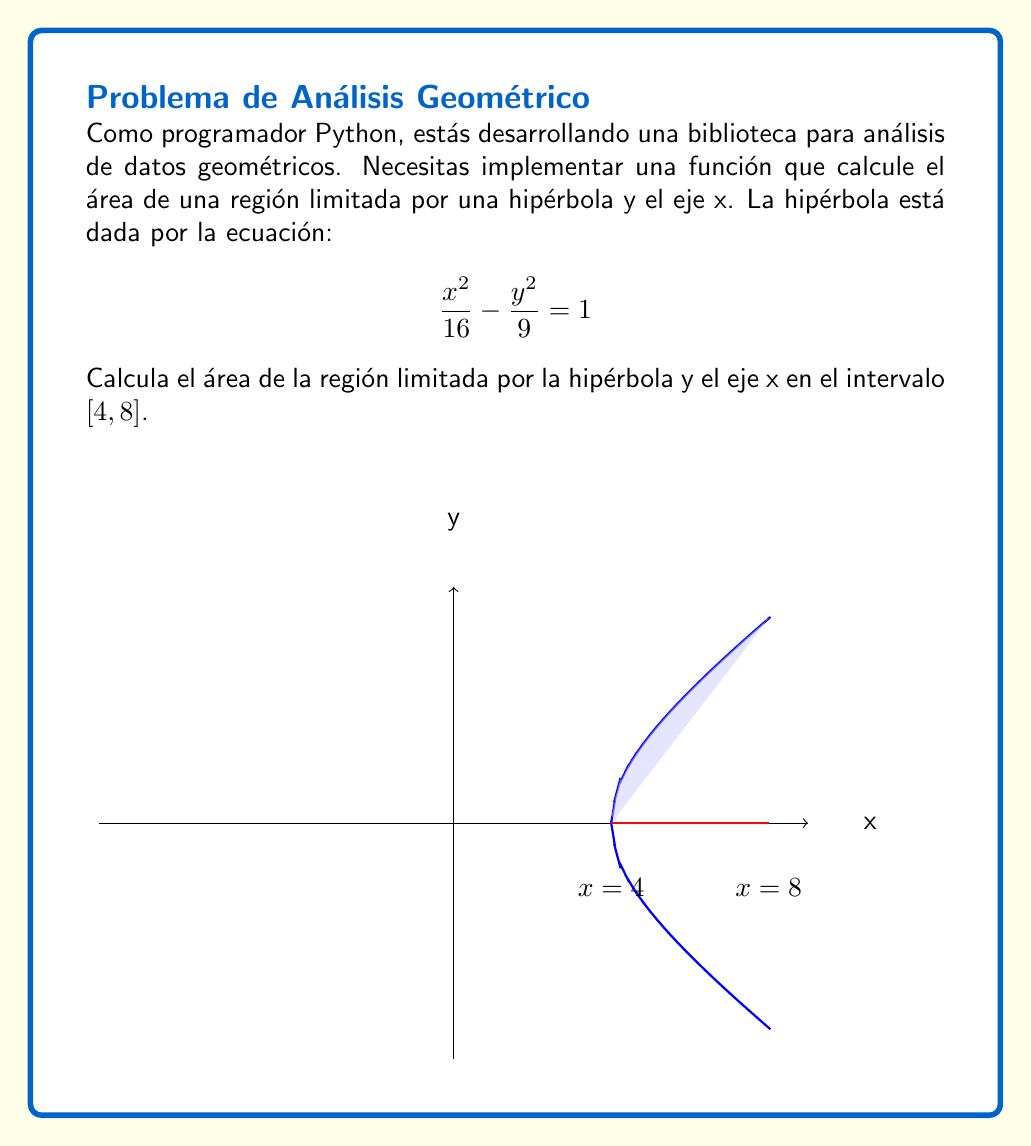What is the answer to this math problem? Para resolver este problema, seguiremos estos pasos:

1) La ecuación de la hipérbola es $\frac{x^2}{16} - \frac{y^2}{9} = 1$. Despejamos y:

   $$\frac{y^2}{9} = \frac{x^2}{16} - 1$$
   $$y^2 = 9(\frac{x^2}{16} - 1)$$
   $$y = \pm 3\sqrt{\frac{x^2}{16} - 1}$$

2) El área que buscamos es la integral definida de la función positiva y en el intervalo [4, 8]:

   $$A = \int_4^8 3\sqrt{\frac{x^2}{16} - 1} dx$$

3) Esta integral no es fácil de resolver directamente. Usaremos la sustitución trigonométrica:
   Sea $x = 4\sec\theta$, entonces $dx = 4\sec\theta\tan\theta d\theta$

4) Los límites de integración cambian:
   Cuando $x = 4$, $\sec\theta = 1$, por lo que $\theta = 0$
   Cuando $x = 8$, $\sec\theta = 2$, por lo que $\theta = \arccos(\frac{1}{2})$

5) Sustituyendo en la integral:

   $$A = \int_0^{\arccos(\frac{1}{2})} 3\sqrt{\frac{16\sec^2\theta}{16} - 1} \cdot 4\sec\theta\tan\theta d\theta$$
   $$= 12\int_0^{\arccos(\frac{1}{2})} \sqrt{\sec^2\theta - 1} \cdot \sec\theta\tan\theta d\theta$$
   $$= 12\int_0^{\arccos(\frac{1}{2})} \tan\theta \cdot \sec\theta\tan\theta d\theta$$
   $$= 12\int_0^{\arccos(\frac{1}{2})} \tan^2\theta \cdot \sec\theta d\theta$$

6) Usando la identidad $\tan^2\theta = \sec^2\theta - 1$:

   $$A = 12\int_0^{\arccos(\frac{1}{2})} (\sec^2\theta - 1) \cdot \sec\theta d\theta$$
   $$= 12\int_0^{\arccos(\frac{1}{2})} (\sec^3\theta - \sec\theta) d\theta$$

7) Integrando:

   $$A = 12[\frac{1}{2}(\sec\theta\tan\theta + \ln|\sec\theta + \tan\theta|) - \ln|\sec\theta + \tan\theta|]_0^{\arccos(\frac{1}{2})}$$

8) Evaluando los límites:

   $$A = 12[\frac{1}{2}(\sqrt{3} + \ln(2+\sqrt{3})) - \ln(2+\sqrt{3}) - (\frac{1}{2}(0 + 0) - 0)]$$
   $$= 12[\frac{1}{2}\sqrt{3} + \frac{1}{2}\ln(2+\sqrt{3}) - \ln(2+\sqrt{3})]$$
   $$= 12[\frac{1}{2}\sqrt{3} - \frac{1}{2}\ln(2+\sqrt{3})]$$
   $$= 6\sqrt{3} - 6\ln(2+\sqrt{3})$$
Answer: $6\sqrt{3} - 6\ln(2+\sqrt{3})$ 